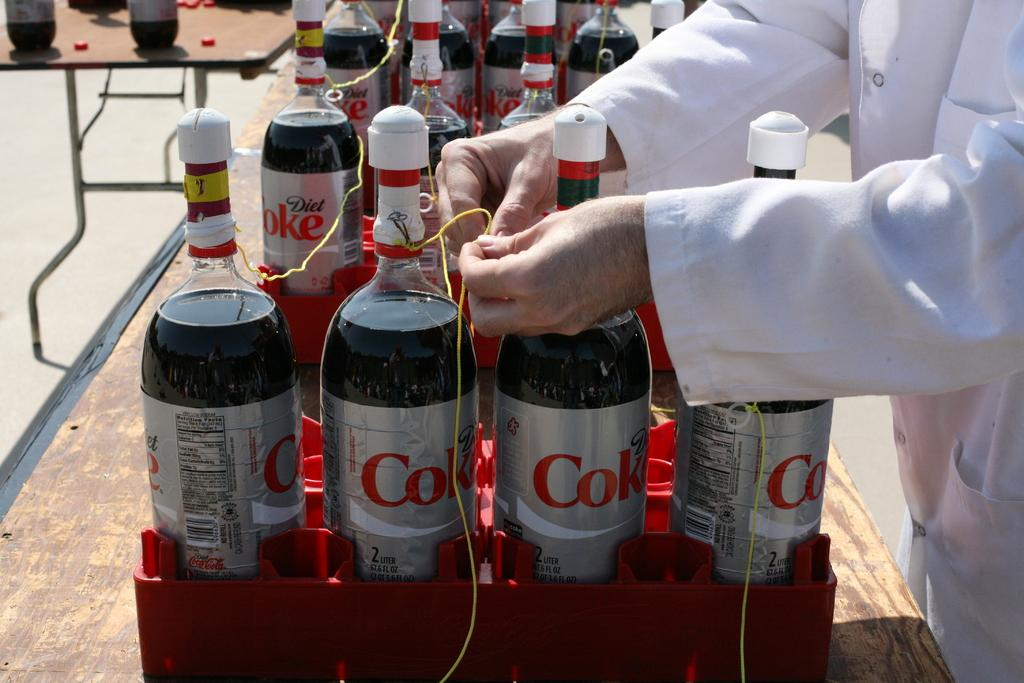What can be seen in the image that is related to bottles? There are many bottles with labels in the image. How are the bottles arranged or stored in the image? The bottles are kept on boxes. What connects the bottles in the image? There are small threads connecting the bottles. Who is present in the image and what are they doing? A person wearing a white coat is present in the image, and they are tying the thread. What type of mountain range can be seen in the background of the image? There is no mountain range visible in the image; it focuses on the bottles and the person tying the thread. 